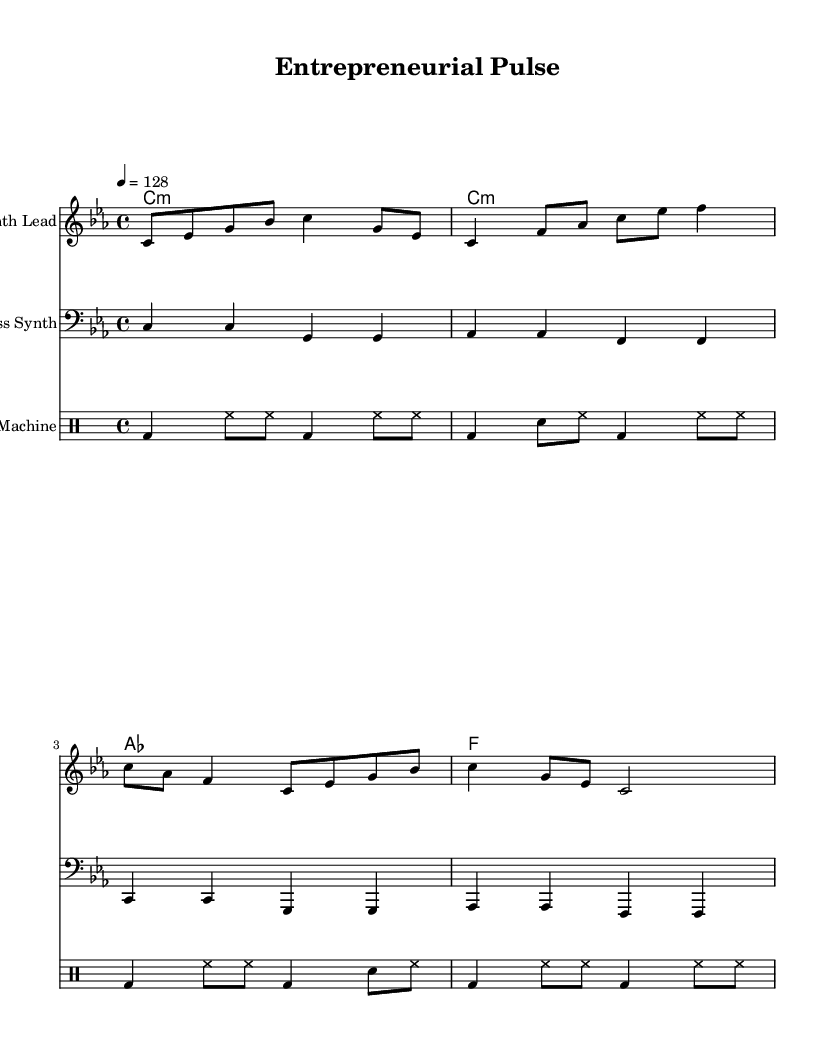What is the key signature of this music? The key signature is C minor, which contains three flats (B♭, E♭, and A♭). This can be determined by looking at the key signature section at the beginning of the staff.
Answer: C minor What is the time signature of this music? The time signature is 4/4, indicated by the numeral "4" over another "4". This means there are four beats in each measure, and the quarter note receives one beat.
Answer: 4/4 What is the tempo marking of this piece? The tempo marking is indicated by the instruction "4 = 128", which means the quarter note should be played at a speed of 128 beats per minute. This is noted above the staff.
Answer: 128 How many measures are there in the synth lead part? By counting the vertical bar lines (measure borders) in the synth lead staff, there are a total of four measures.
Answer: 4 Which chord appears most frequently in the chord progression? The chord "C minor" appears twice in the chord progression notation within the chord names above the staves, indicating it is the most frequently used chord in this piece.
Answer: C minor What kind of drum pattern is used in this music? The drum pattern consists primarily of bass drum (bd), hi-hat (hh), and snare drum (sn) hits, which is typical for dance music aiming for a driving beat. This can be recognized by observing the drummode section.
Answer: Dance drum pattern What is the primary motif used in the synth lead? The primary motif in the synth lead features a sequence of ascending and descending notes starting from C, creating an energetic and driving feel typical in techno music. This can be inferred from the melodic notes arranged in a recognizable sequence.
Answer: Ascending and descending motif 